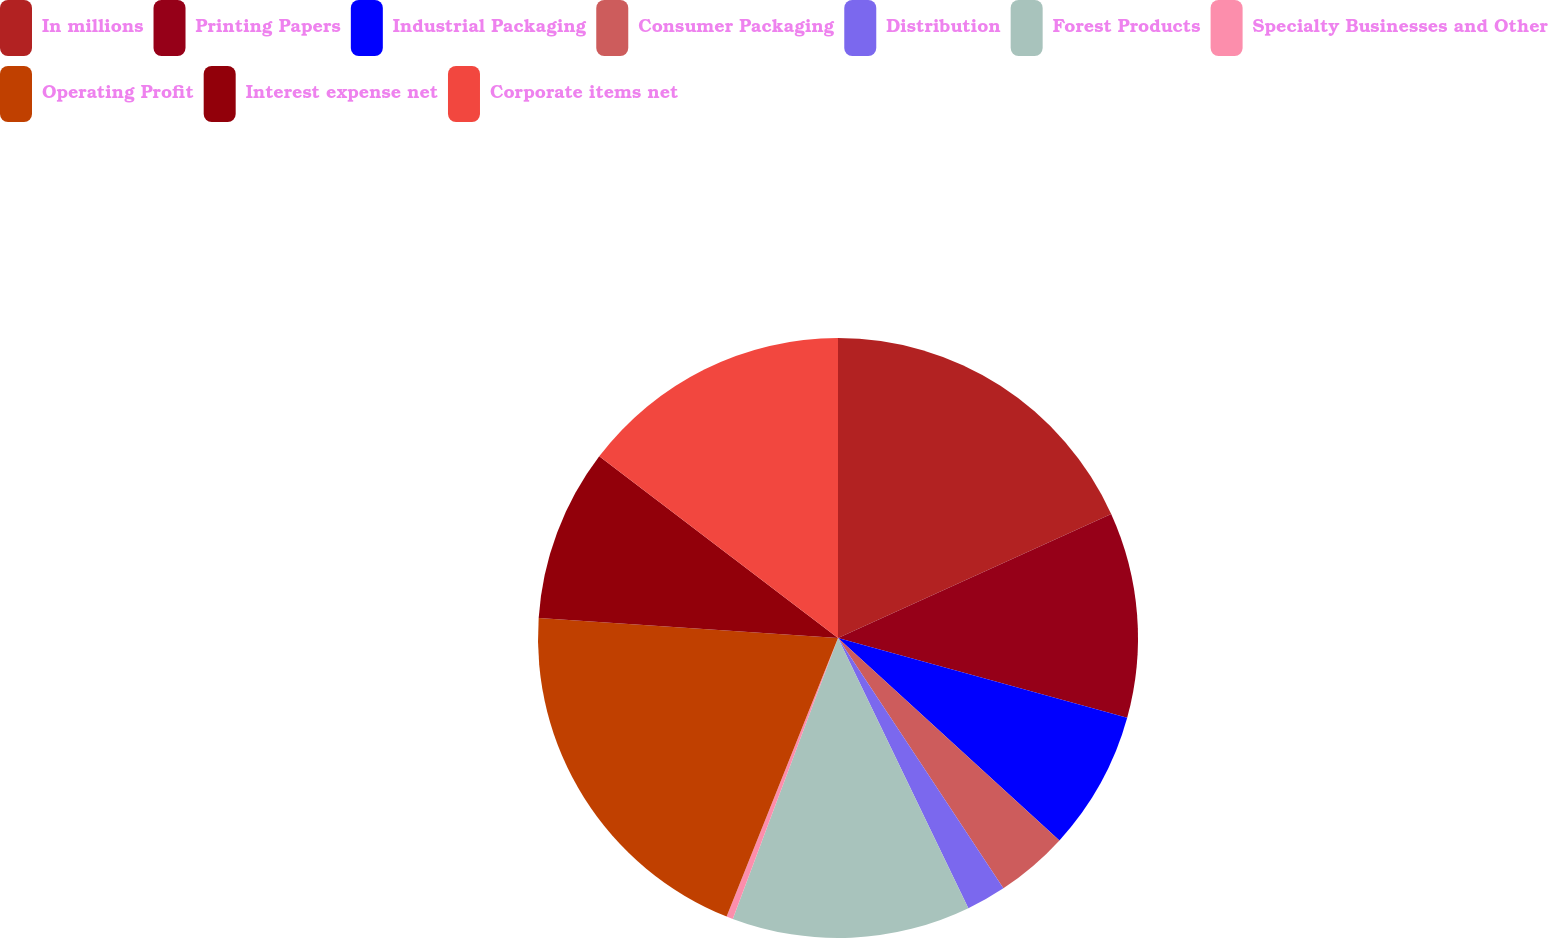Convert chart to OTSL. <chart><loc_0><loc_0><loc_500><loc_500><pie_chart><fcel>In millions<fcel>Printing Papers<fcel>Industrial Packaging<fcel>Consumer Packaging<fcel>Distribution<fcel>Forest Products<fcel>Specialty Businesses and Other<fcel>Operating Profit<fcel>Interest expense net<fcel>Corporate items net<nl><fcel>18.22%<fcel>11.07%<fcel>7.5%<fcel>3.92%<fcel>2.14%<fcel>12.86%<fcel>0.35%<fcel>20.01%<fcel>9.29%<fcel>14.65%<nl></chart> 